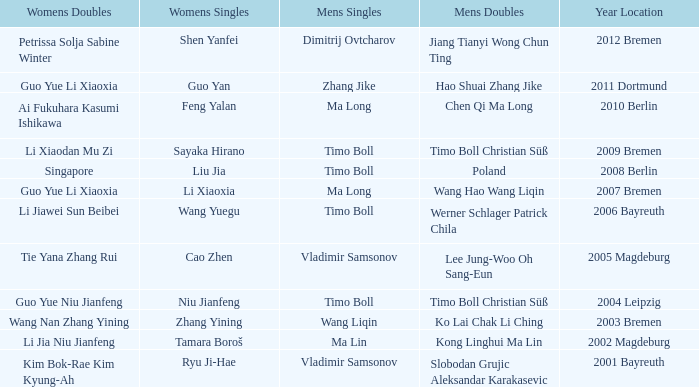Who won Womens Singles in the year that Ma Lin won Mens Singles? Tamara Boroš. 